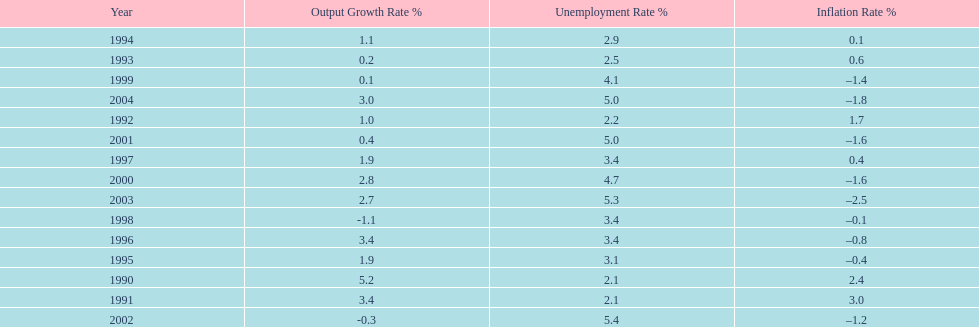What year had the highest unemployment rate? 2002. 